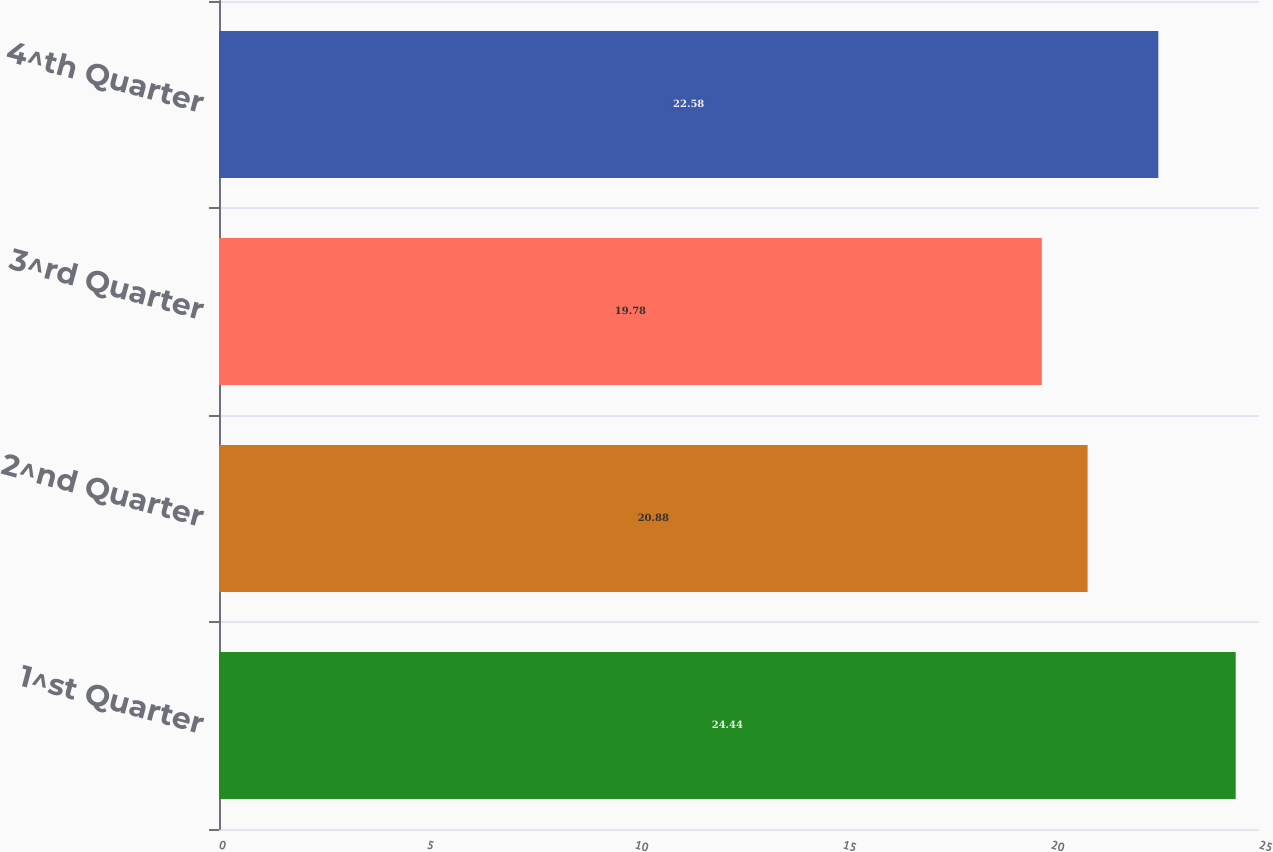Convert chart. <chart><loc_0><loc_0><loc_500><loc_500><bar_chart><fcel>1^st Quarter<fcel>2^nd Quarter<fcel>3^rd Quarter<fcel>4^th Quarter<nl><fcel>24.44<fcel>20.88<fcel>19.78<fcel>22.58<nl></chart> 